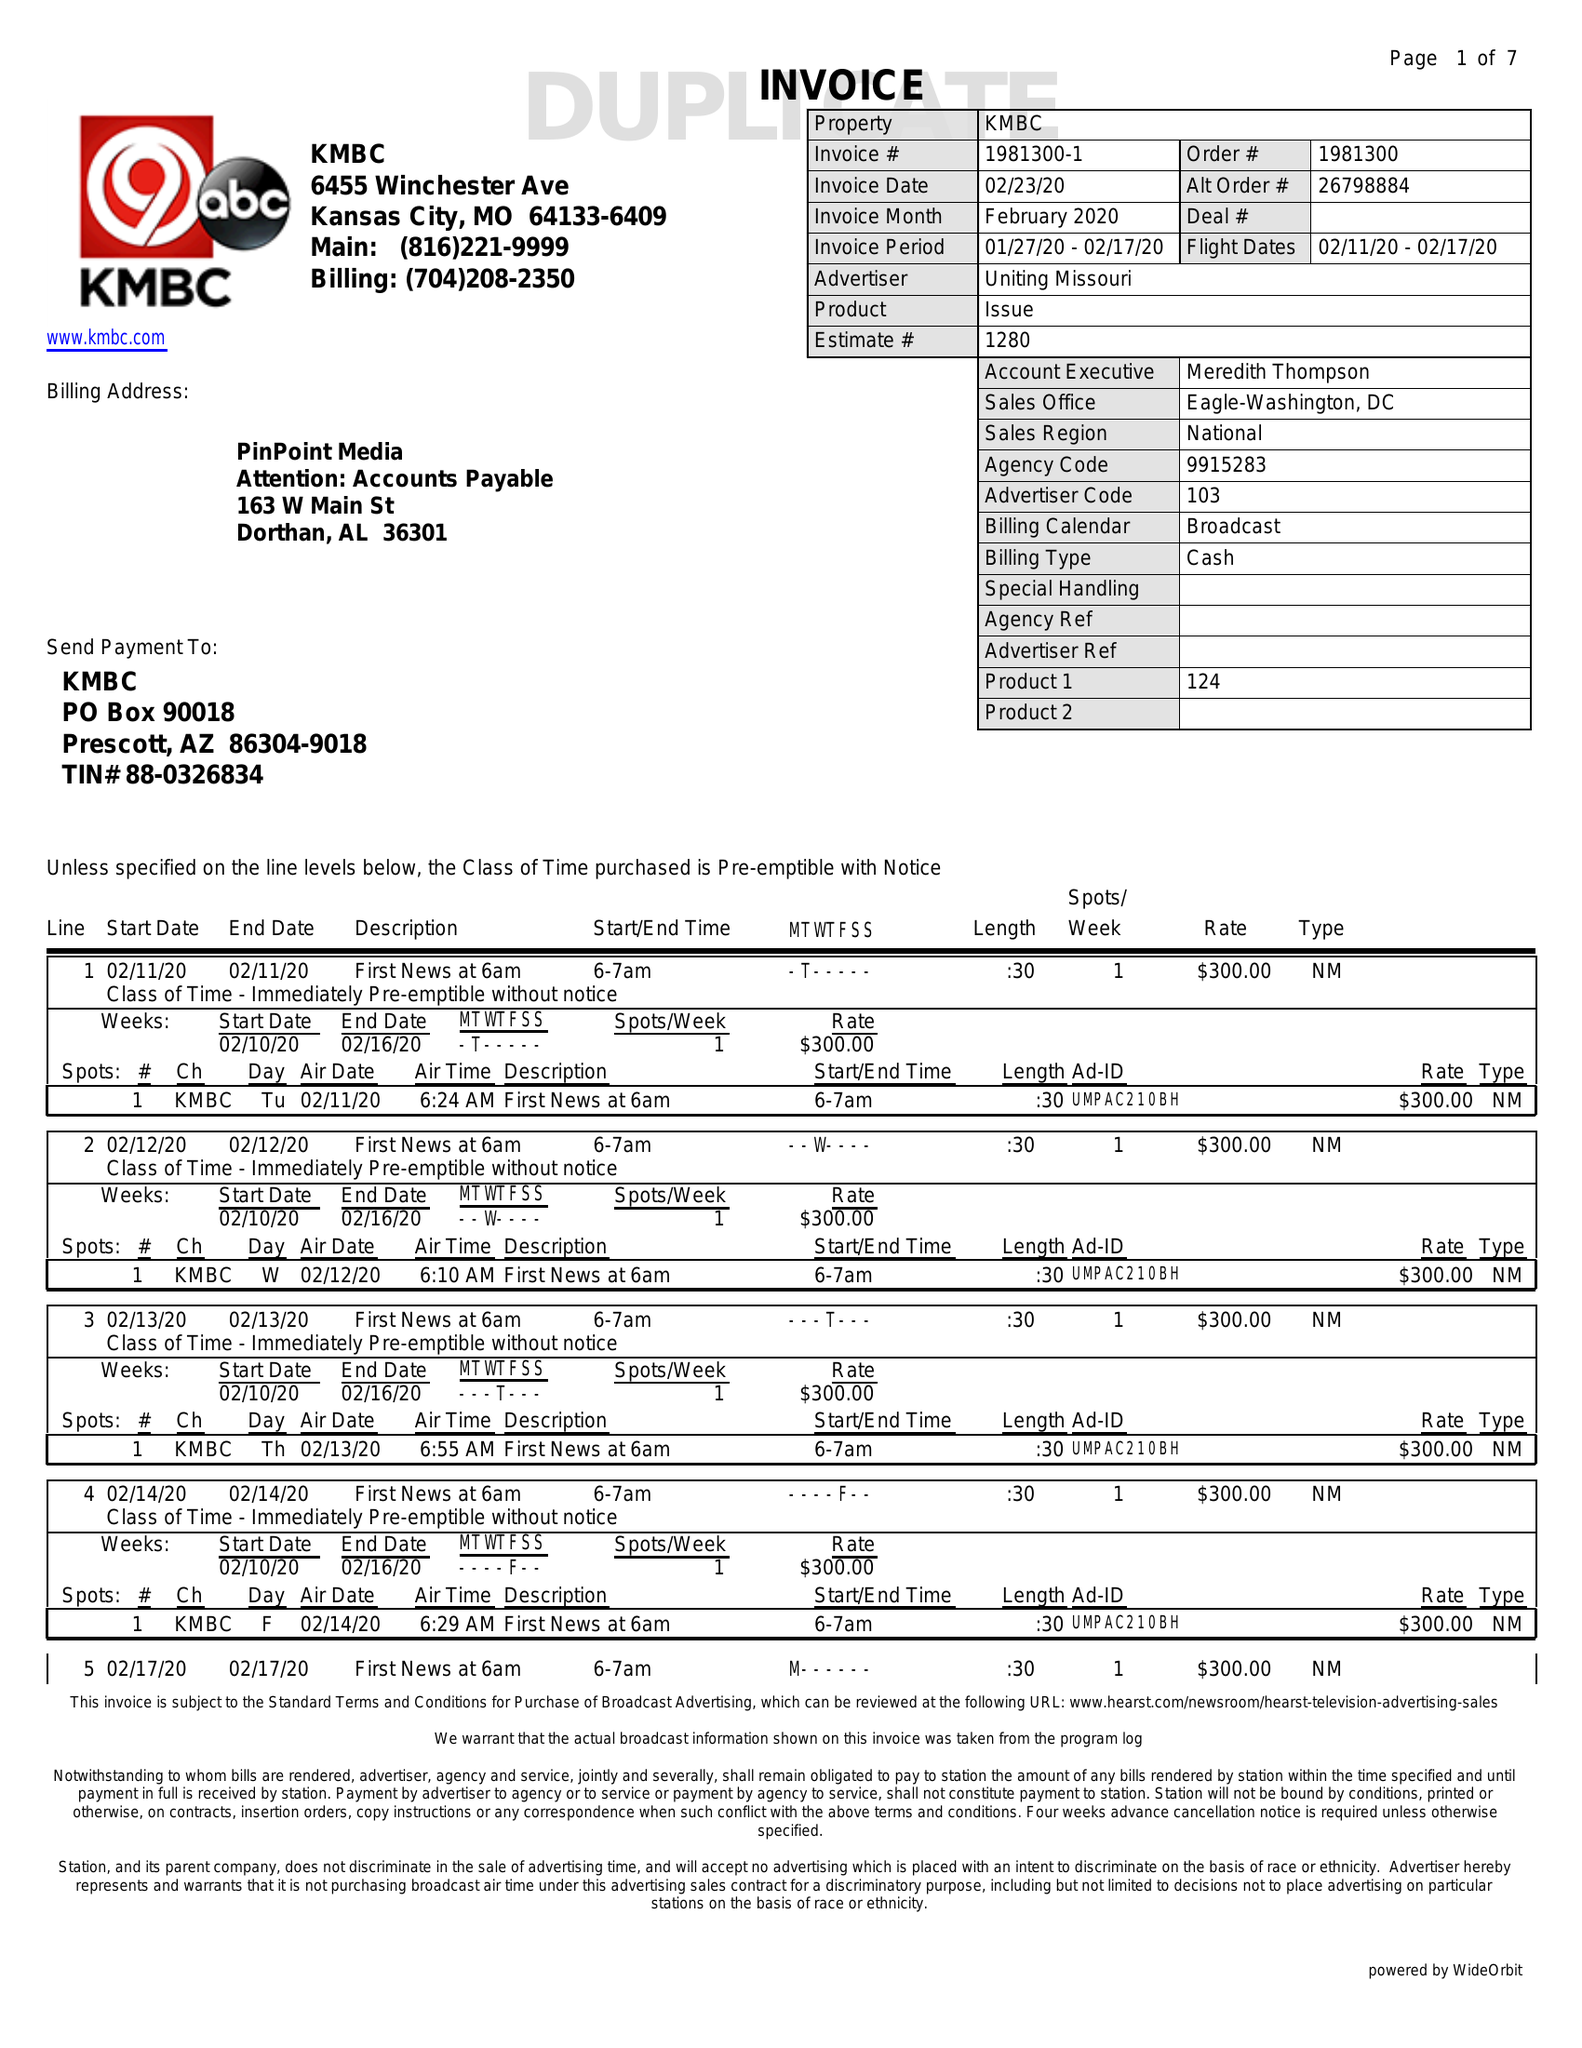What is the value for the flight_to?
Answer the question using a single word or phrase. 02/17/20 